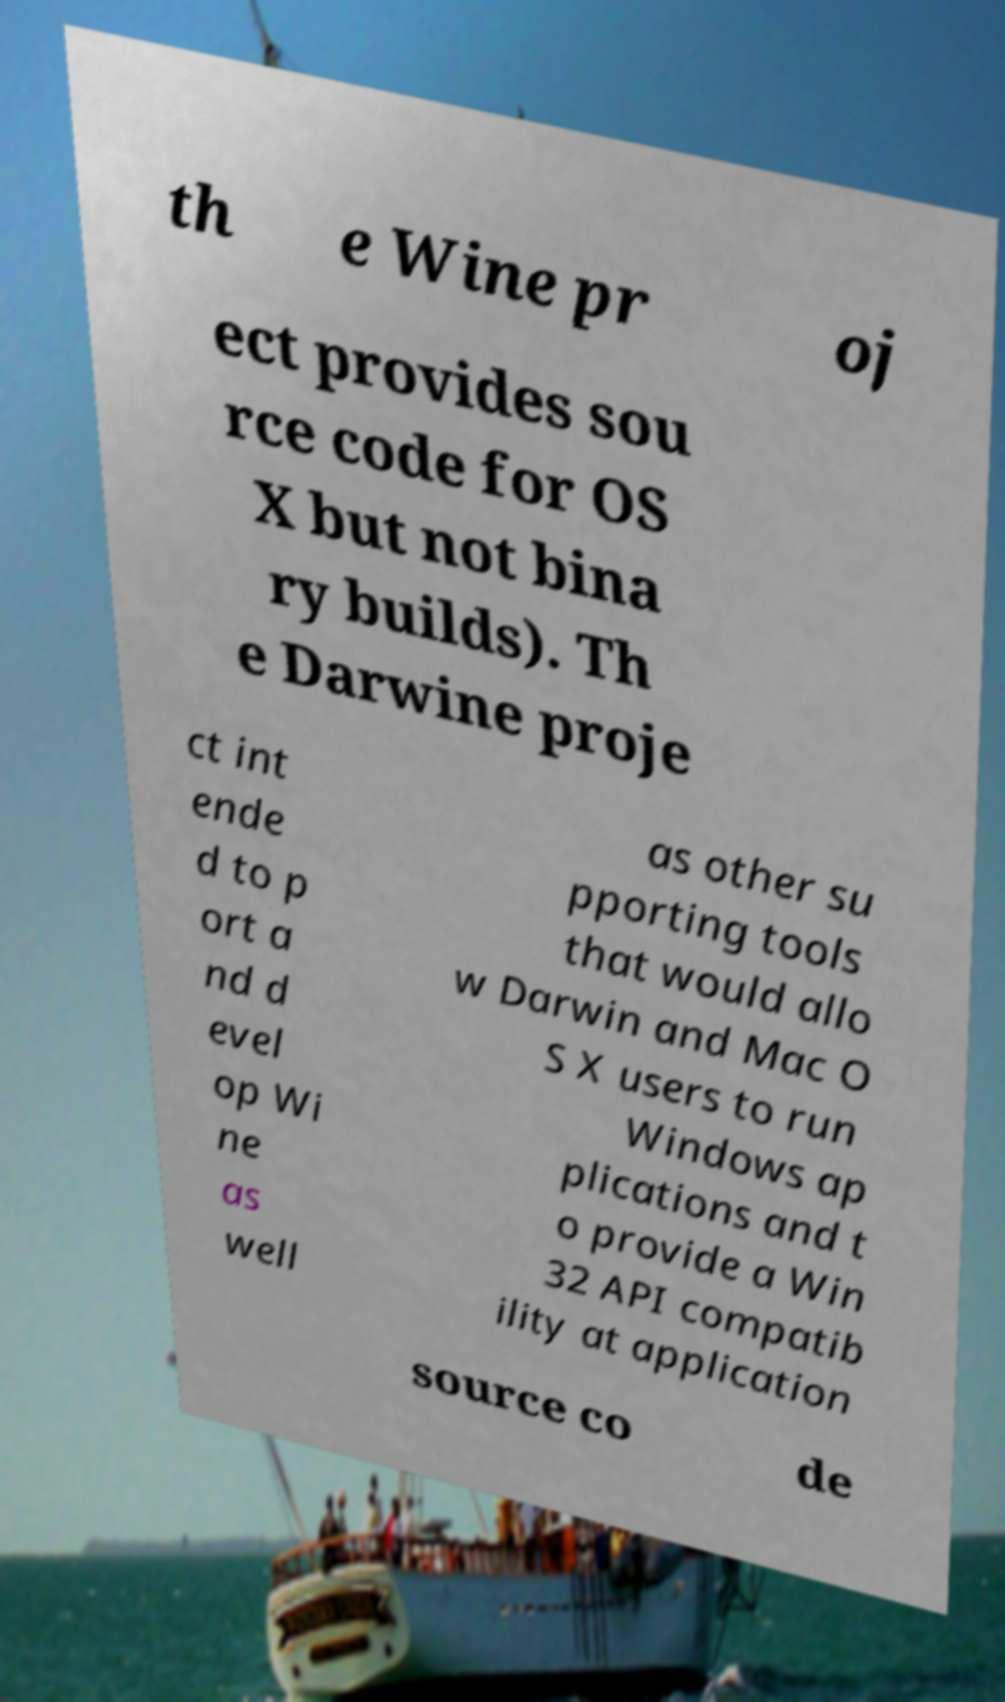Please read and relay the text visible in this image. What does it say? th e Wine pr oj ect provides sou rce code for OS X but not bina ry builds). Th e Darwine proje ct int ende d to p ort a nd d evel op Wi ne as well as other su pporting tools that would allo w Darwin and Mac O S X users to run Windows ap plications and t o provide a Win 32 API compatib ility at application source co de 